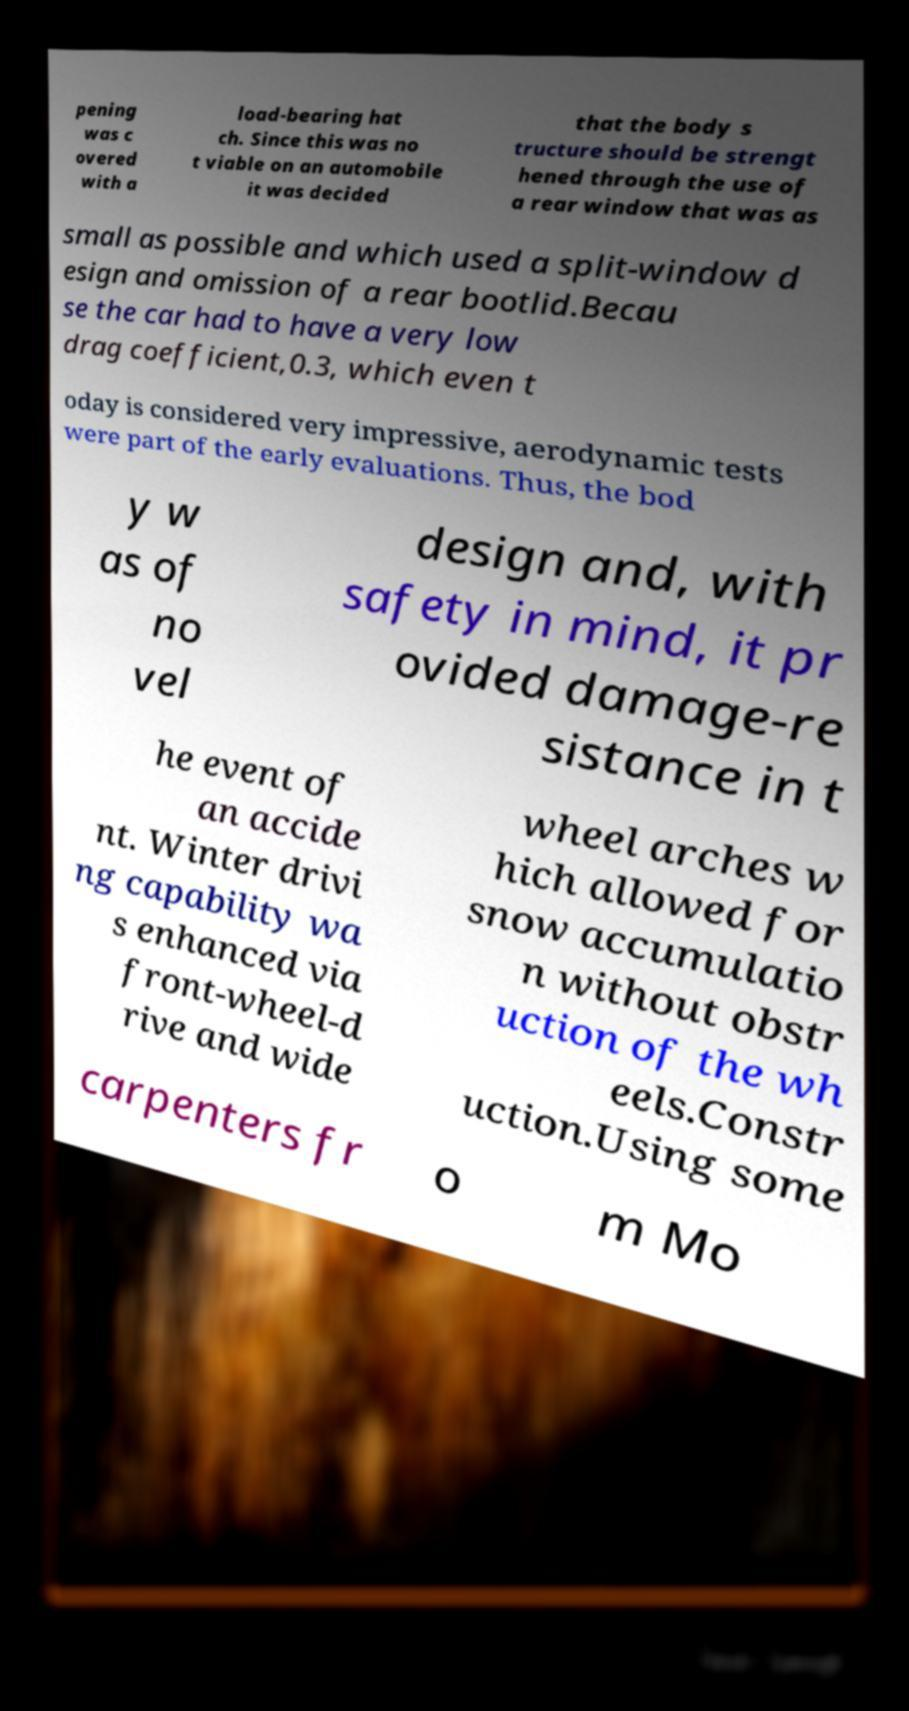Can you read and provide the text displayed in the image?This photo seems to have some interesting text. Can you extract and type it out for me? pening was c overed with a load-bearing hat ch. Since this was no t viable on an automobile it was decided that the body s tructure should be strengt hened through the use of a rear window that was as small as possible and which used a split-window d esign and omission of a rear bootlid.Becau se the car had to have a very low drag coefficient,0.3, which even t oday is considered very impressive, aerodynamic tests were part of the early evaluations. Thus, the bod y w as of no vel design and, with safety in mind, it pr ovided damage-re sistance in t he event of an accide nt. Winter drivi ng capability wa s enhanced via front-wheel-d rive and wide wheel arches w hich allowed for snow accumulatio n without obstr uction of the wh eels.Constr uction.Using some carpenters fr o m Mo 